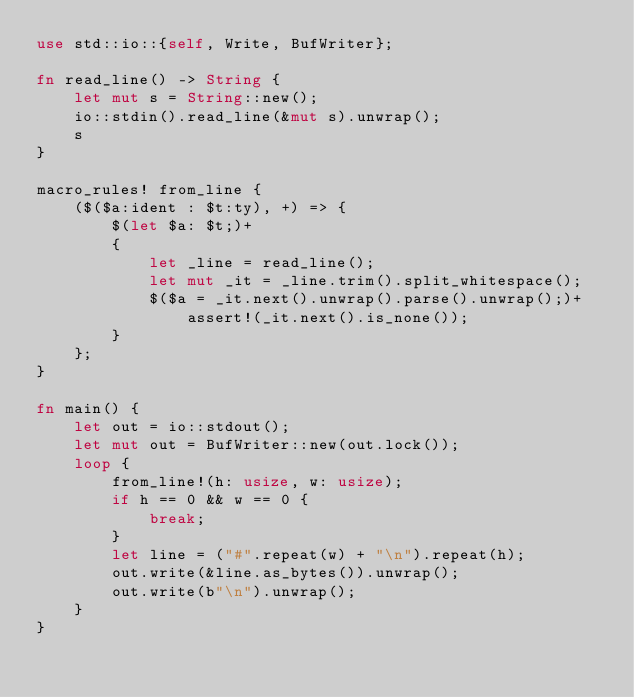Convert code to text. <code><loc_0><loc_0><loc_500><loc_500><_Rust_>use std::io::{self, Write, BufWriter};

fn read_line() -> String {
    let mut s = String::new();
    io::stdin().read_line(&mut s).unwrap();
    s
}

macro_rules! from_line {
    ($($a:ident : $t:ty), +) => {
        $(let $a: $t;)+
        {
            let _line = read_line();
            let mut _it = _line.trim().split_whitespace();
            $($a = _it.next().unwrap().parse().unwrap();)+
                assert!(_it.next().is_none());
        }
    };
}

fn main() {
    let out = io::stdout();
    let mut out = BufWriter::new(out.lock());
    loop {
        from_line!(h: usize, w: usize);
        if h == 0 && w == 0 {
            break;
        }
        let line = ("#".repeat(w) + "\n").repeat(h);
        out.write(&line.as_bytes()).unwrap();
        out.write(b"\n").unwrap();
    }
}
</code> 